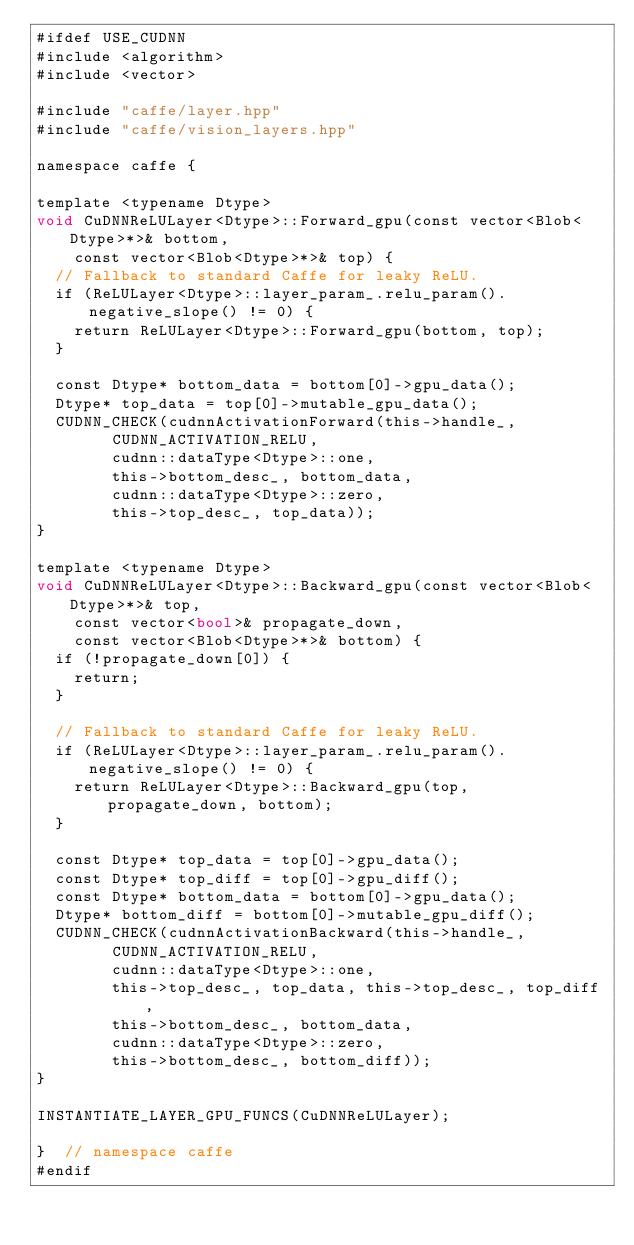<code> <loc_0><loc_0><loc_500><loc_500><_Cuda_>#ifdef USE_CUDNN
#include <algorithm>
#include <vector>

#include "caffe/layer.hpp"
#include "caffe/vision_layers.hpp"

namespace caffe {

template <typename Dtype>
void CuDNNReLULayer<Dtype>::Forward_gpu(const vector<Blob<Dtype>*>& bottom,
    const vector<Blob<Dtype>*>& top) {
  // Fallback to standard Caffe for leaky ReLU.
  if (ReLULayer<Dtype>::layer_param_.relu_param().negative_slope() != 0) {
    return ReLULayer<Dtype>::Forward_gpu(bottom, top);
  }

  const Dtype* bottom_data = bottom[0]->gpu_data();
  Dtype* top_data = top[0]->mutable_gpu_data();
  CUDNN_CHECK(cudnnActivationForward(this->handle_,
        CUDNN_ACTIVATION_RELU,
        cudnn::dataType<Dtype>::one,
        this->bottom_desc_, bottom_data,
        cudnn::dataType<Dtype>::zero,
        this->top_desc_, top_data));
}

template <typename Dtype>
void CuDNNReLULayer<Dtype>::Backward_gpu(const vector<Blob<Dtype>*>& top,
    const vector<bool>& propagate_down,
    const vector<Blob<Dtype>*>& bottom) {
  if (!propagate_down[0]) {
    return;
  }

  // Fallback to standard Caffe for leaky ReLU.
  if (ReLULayer<Dtype>::layer_param_.relu_param().negative_slope() != 0) {
    return ReLULayer<Dtype>::Backward_gpu(top, propagate_down, bottom);
  }

  const Dtype* top_data = top[0]->gpu_data();
  const Dtype* top_diff = top[0]->gpu_diff();
  const Dtype* bottom_data = bottom[0]->gpu_data();
  Dtype* bottom_diff = bottom[0]->mutable_gpu_diff();
  CUDNN_CHECK(cudnnActivationBackward(this->handle_,
        CUDNN_ACTIVATION_RELU,
        cudnn::dataType<Dtype>::one,
        this->top_desc_, top_data, this->top_desc_, top_diff,
        this->bottom_desc_, bottom_data,
        cudnn::dataType<Dtype>::zero,
        this->bottom_desc_, bottom_diff));
}

INSTANTIATE_LAYER_GPU_FUNCS(CuDNNReLULayer);

}  // namespace caffe
#endif
</code> 